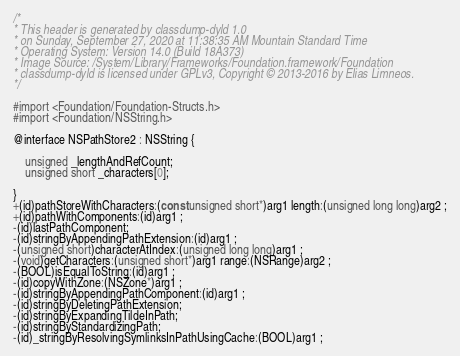Convert code to text. <code><loc_0><loc_0><loc_500><loc_500><_C_>/*
* This header is generated by classdump-dyld 1.0
* on Sunday, September 27, 2020 at 11:38:35 AM Mountain Standard Time
* Operating System: Version 14.0 (Build 18A373)
* Image Source: /System/Library/Frameworks/Foundation.framework/Foundation
* classdump-dyld is licensed under GPLv3, Copyright © 2013-2016 by Elias Limneos.
*/

#import <Foundation/Foundation-Structs.h>
#import <Foundation/NSString.h>

@interface NSPathStore2 : NSString {

	unsigned _lengthAndRefCount;
	unsigned short _characters[0];

}
+(id)pathStoreWithCharacters:(const unsigned short*)arg1 length:(unsigned long long)arg2 ;
+(id)pathWithComponents:(id)arg1 ;
-(id)lastPathComponent;
-(id)stringByAppendingPathExtension:(id)arg1 ;
-(unsigned short)characterAtIndex:(unsigned long long)arg1 ;
-(void)getCharacters:(unsigned short*)arg1 range:(NSRange)arg2 ;
-(BOOL)isEqualToString:(id)arg1 ;
-(id)copyWithZone:(NSZone*)arg1 ;
-(id)stringByAppendingPathComponent:(id)arg1 ;
-(id)stringByDeletingPathExtension;
-(id)stringByExpandingTildeInPath;
-(id)stringByStandardizingPath;
-(id)_stringByResolvingSymlinksInPathUsingCache:(BOOL)arg1 ;</code> 